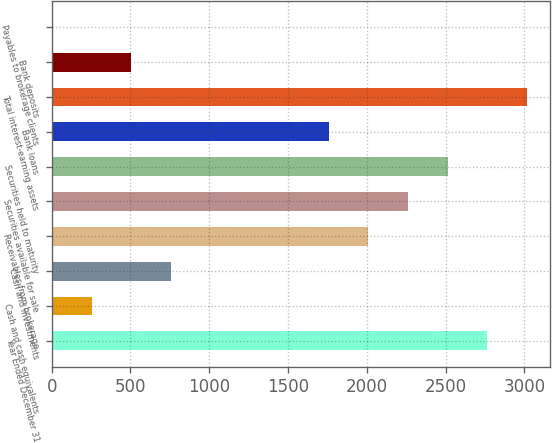Convert chart to OTSL. <chart><loc_0><loc_0><loc_500><loc_500><bar_chart><fcel>Year Ended December 31<fcel>Cash and cash equivalents<fcel>Cash and investments<fcel>Receivables from brokerage<fcel>Securities available for sale<fcel>Securities held to maturity<fcel>Bank loans<fcel>Total interest-earning assets<fcel>Bank deposits<fcel>Payables to brokerage clients<nl><fcel>2763<fcel>253<fcel>755<fcel>2010<fcel>2261<fcel>2512<fcel>1759<fcel>3014<fcel>504<fcel>2<nl></chart> 